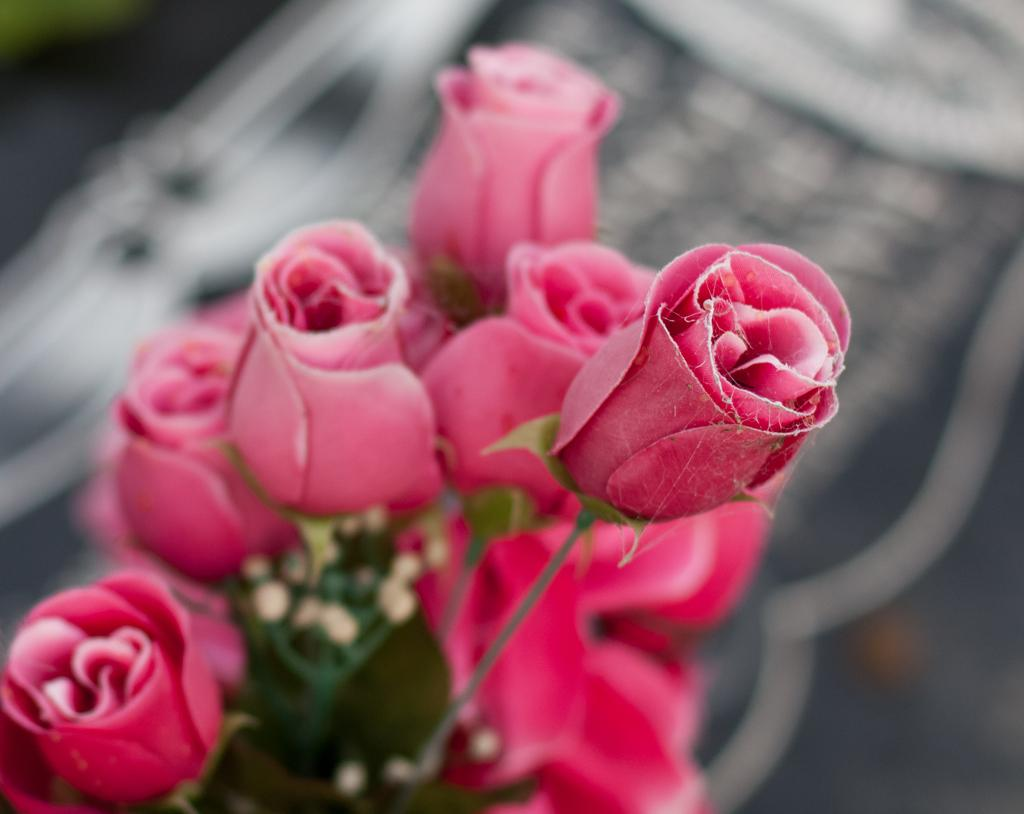What type of plants are in the image? There are flowers in the image. What color are the flowers? The flowers are pink. Can you describe the background of the image? The background of the image is blurred. What type of pie is being served in the image? There is no pie present in the image; it features pink flowers with a blurred background. 